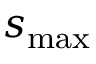Convert formula to latex. <formula><loc_0><loc_0><loc_500><loc_500>s _ { \max }</formula> 